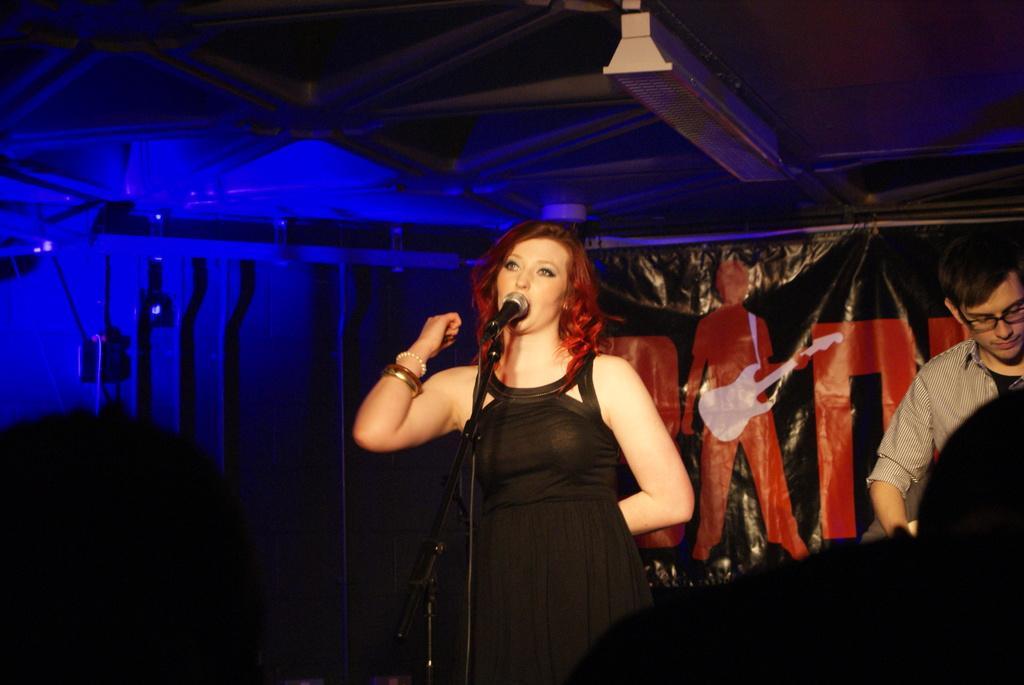How would you summarize this image in a sentence or two? In the image there is a lady standing. In front of her there is a stand with mic. And on the right side of the image there is a man with spectacles. Behind them there is banner. In the background there are pipes. At the top of the image there is ceiling with a light. 